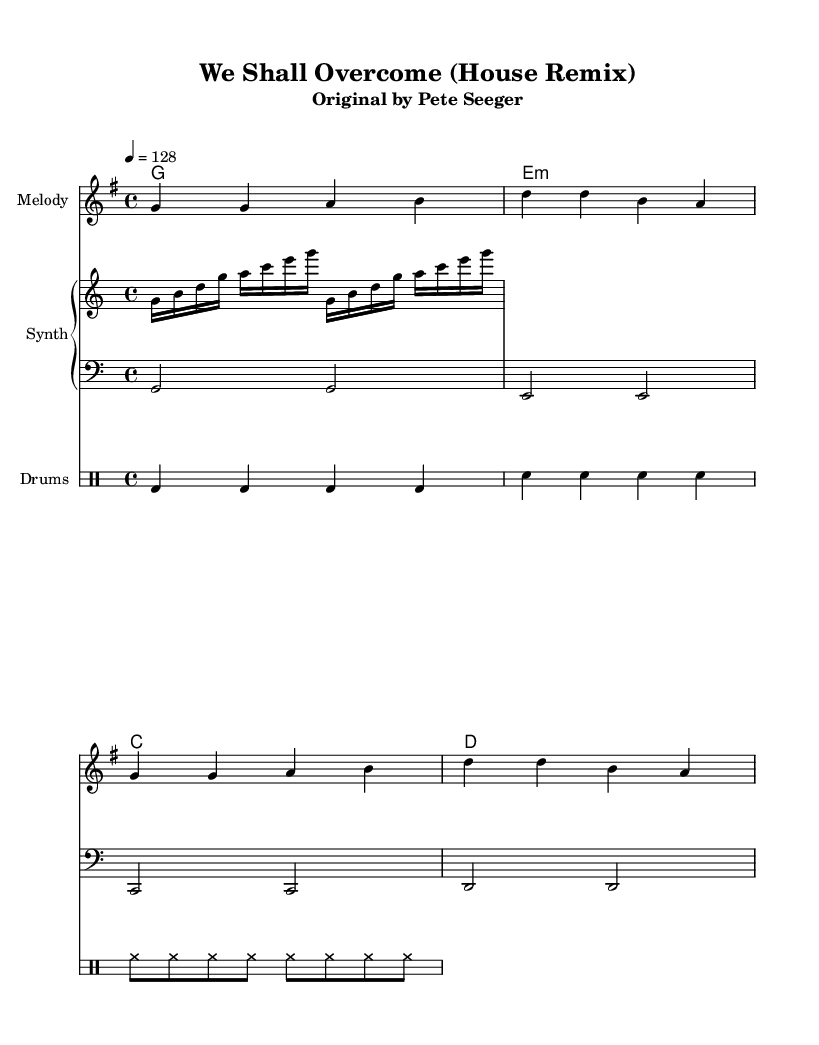What is the key signature of this music? The key signature is indicated by the absence of sharps or flats in the staff, which points to G major.
Answer: G major What is the time signature of this music? The time signature is shown at the beginning of the staff, represented by the fraction 4/4.
Answer: 4/4 What is the tempo marking indicated in this music? The tempo marking tells us the speed of the piece, which is indicated as "4 = 128." This means there are 128 beats per minute.
Answer: 128 How many measures are there in the melody section? Counting the measures in the melody part, there are four groups separated by the vertical lines, indicating four measures total.
Answer: 4 Which chord is played in the first measure of the harmony section? Looking at the harmony section, the first measure contains the chord G, which is notated as a single note G below the chord names.
Answer: G What type of rhythm is indicated for the bass line? The bass line consists of half notes, and each note lasts for two beats, which can be determined from the note values.
Answer: Half notes What instrument is indicated for the arpeggiator section? The arpeggiator is notated in a staff labeled as "Synth," indicating it is played on a synthesizer.
Answer: Synth 